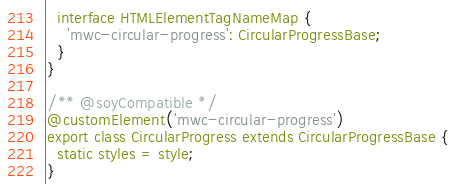<code> <loc_0><loc_0><loc_500><loc_500><_TypeScript_>  interface HTMLElementTagNameMap {
    'mwc-circular-progress': CircularProgressBase;
  }
}

/** @soyCompatible */
@customElement('mwc-circular-progress')
export class CircularProgress extends CircularProgressBase {
  static styles = style;
}
</code> 